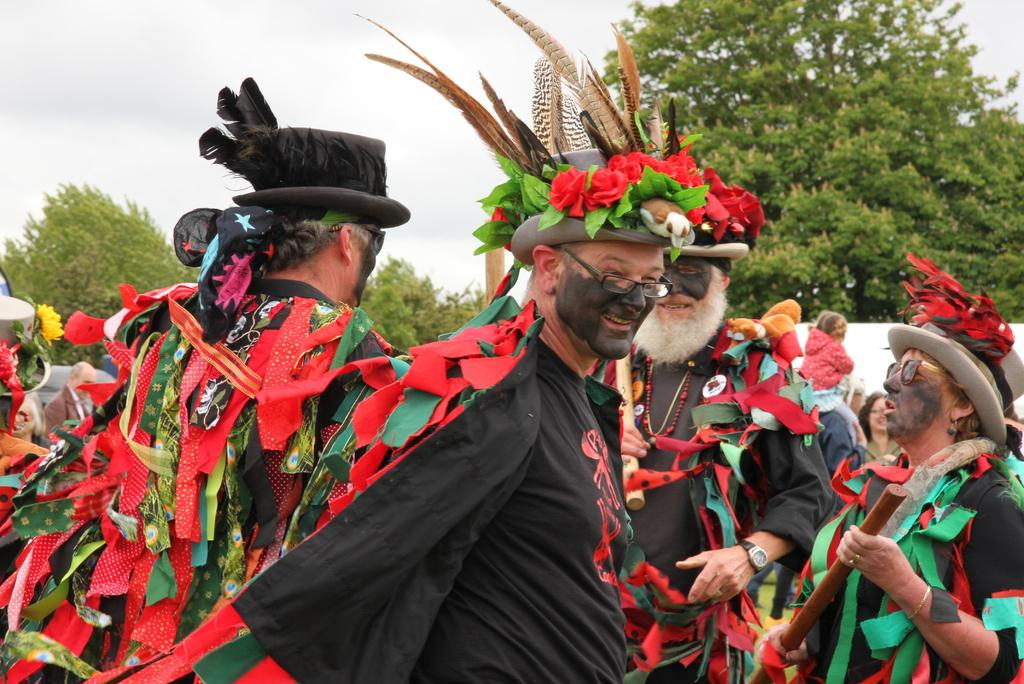What are the people in the image wearing? There are many people wearing costumes in the image. What are the people holding in their hands? There are people holding objects in their hands in the image. What can be seen in the sky in the image? The sky is visible in the image. What type of vegetation is present in the image? There are trees in the image. What type of picture is hanging from the wrist of one of the people in the image? There is no picture hanging from anyone's wrist in the image. How does the health of the trees in the image affect the overall mood of the scene? The health of the trees is not mentioned in the image, so it cannot be determined how it might affect the overall mood of the scene. 